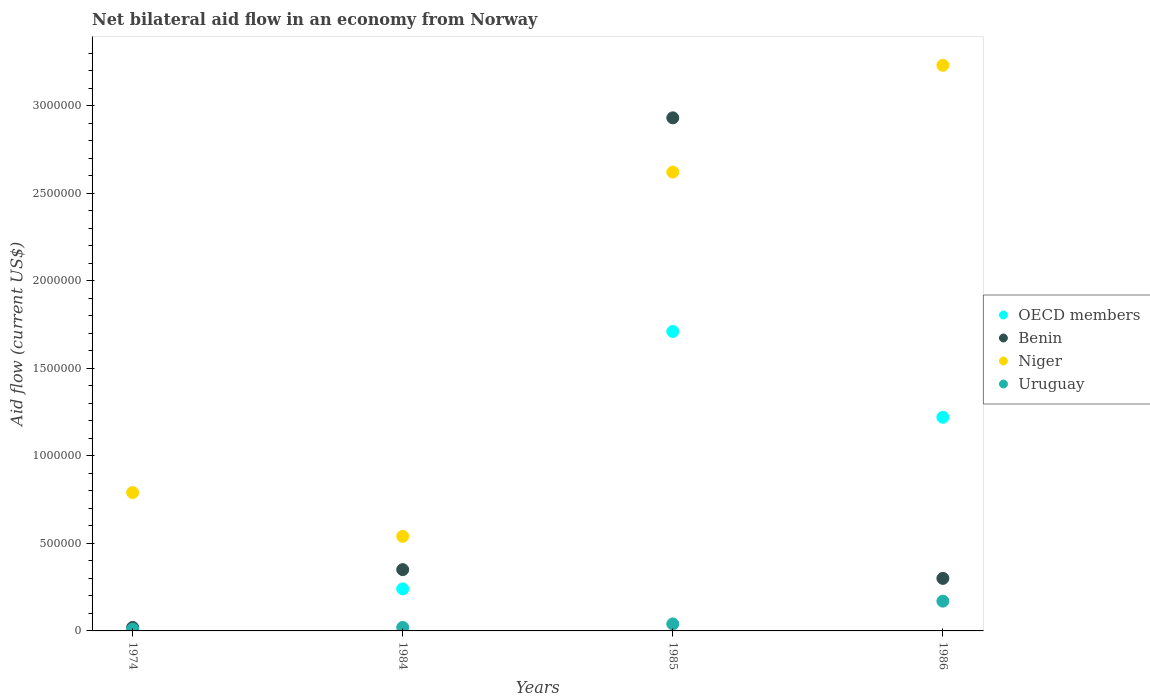Is the number of dotlines equal to the number of legend labels?
Keep it short and to the point. No. What is the net bilateral aid flow in OECD members in 1984?
Your answer should be very brief. 2.40e+05. Across all years, what is the maximum net bilateral aid flow in OECD members?
Offer a terse response. 1.71e+06. Across all years, what is the minimum net bilateral aid flow in Benin?
Offer a very short reply. 2.00e+04. What is the total net bilateral aid flow in OECD members in the graph?
Your answer should be very brief. 3.17e+06. What is the average net bilateral aid flow in Benin per year?
Your answer should be very brief. 9.00e+05. In how many years, is the net bilateral aid flow in Niger greater than 1500000 US$?
Your answer should be compact. 2. What is the ratio of the net bilateral aid flow in Uruguay in 1984 to that in 1985?
Give a very brief answer. 0.5. What is the difference between the highest and the lowest net bilateral aid flow in Benin?
Your answer should be very brief. 2.91e+06. Is it the case that in every year, the sum of the net bilateral aid flow in OECD members and net bilateral aid flow in Niger  is greater than the sum of net bilateral aid flow in Benin and net bilateral aid flow in Uruguay?
Your answer should be compact. No. Does the net bilateral aid flow in Benin monotonically increase over the years?
Your answer should be compact. No. Is the net bilateral aid flow in Niger strictly greater than the net bilateral aid flow in Uruguay over the years?
Offer a very short reply. Yes. How many dotlines are there?
Ensure brevity in your answer.  4. How many years are there in the graph?
Provide a short and direct response. 4. What is the difference between two consecutive major ticks on the Y-axis?
Provide a short and direct response. 5.00e+05. Does the graph contain any zero values?
Provide a short and direct response. Yes. Where does the legend appear in the graph?
Your response must be concise. Center right. How are the legend labels stacked?
Ensure brevity in your answer.  Vertical. What is the title of the graph?
Keep it short and to the point. Net bilateral aid flow in an economy from Norway. What is the label or title of the Y-axis?
Offer a terse response. Aid flow (current US$). What is the Aid flow (current US$) in Niger in 1974?
Provide a succinct answer. 7.90e+05. What is the Aid flow (current US$) in OECD members in 1984?
Provide a succinct answer. 2.40e+05. What is the Aid flow (current US$) of Benin in 1984?
Offer a terse response. 3.50e+05. What is the Aid flow (current US$) in Niger in 1984?
Your response must be concise. 5.40e+05. What is the Aid flow (current US$) of Uruguay in 1984?
Your answer should be very brief. 2.00e+04. What is the Aid flow (current US$) of OECD members in 1985?
Offer a very short reply. 1.71e+06. What is the Aid flow (current US$) of Benin in 1985?
Ensure brevity in your answer.  2.93e+06. What is the Aid flow (current US$) in Niger in 1985?
Offer a very short reply. 2.62e+06. What is the Aid flow (current US$) of Uruguay in 1985?
Your response must be concise. 4.00e+04. What is the Aid flow (current US$) in OECD members in 1986?
Ensure brevity in your answer.  1.22e+06. What is the Aid flow (current US$) in Benin in 1986?
Ensure brevity in your answer.  3.00e+05. What is the Aid flow (current US$) in Niger in 1986?
Your response must be concise. 3.23e+06. What is the Aid flow (current US$) of Uruguay in 1986?
Ensure brevity in your answer.  1.70e+05. Across all years, what is the maximum Aid flow (current US$) of OECD members?
Provide a succinct answer. 1.71e+06. Across all years, what is the maximum Aid flow (current US$) of Benin?
Provide a succinct answer. 2.93e+06. Across all years, what is the maximum Aid flow (current US$) in Niger?
Your response must be concise. 3.23e+06. Across all years, what is the maximum Aid flow (current US$) in Uruguay?
Your answer should be compact. 1.70e+05. Across all years, what is the minimum Aid flow (current US$) in OECD members?
Provide a succinct answer. 0. Across all years, what is the minimum Aid flow (current US$) in Niger?
Your response must be concise. 5.40e+05. What is the total Aid flow (current US$) of OECD members in the graph?
Provide a succinct answer. 3.17e+06. What is the total Aid flow (current US$) in Benin in the graph?
Offer a very short reply. 3.60e+06. What is the total Aid flow (current US$) in Niger in the graph?
Provide a succinct answer. 7.18e+06. What is the total Aid flow (current US$) in Uruguay in the graph?
Offer a terse response. 2.40e+05. What is the difference between the Aid flow (current US$) of Benin in 1974 and that in 1984?
Your response must be concise. -3.30e+05. What is the difference between the Aid flow (current US$) in Niger in 1974 and that in 1984?
Keep it short and to the point. 2.50e+05. What is the difference between the Aid flow (current US$) in Uruguay in 1974 and that in 1984?
Keep it short and to the point. -10000. What is the difference between the Aid flow (current US$) of Benin in 1974 and that in 1985?
Your response must be concise. -2.91e+06. What is the difference between the Aid flow (current US$) of Niger in 1974 and that in 1985?
Offer a terse response. -1.83e+06. What is the difference between the Aid flow (current US$) of Benin in 1974 and that in 1986?
Your answer should be compact. -2.80e+05. What is the difference between the Aid flow (current US$) in Niger in 1974 and that in 1986?
Give a very brief answer. -2.44e+06. What is the difference between the Aid flow (current US$) in Uruguay in 1974 and that in 1986?
Provide a succinct answer. -1.60e+05. What is the difference between the Aid flow (current US$) of OECD members in 1984 and that in 1985?
Ensure brevity in your answer.  -1.47e+06. What is the difference between the Aid flow (current US$) of Benin in 1984 and that in 1985?
Keep it short and to the point. -2.58e+06. What is the difference between the Aid flow (current US$) in Niger in 1984 and that in 1985?
Offer a very short reply. -2.08e+06. What is the difference between the Aid flow (current US$) of OECD members in 1984 and that in 1986?
Your answer should be compact. -9.80e+05. What is the difference between the Aid flow (current US$) in Benin in 1984 and that in 1986?
Give a very brief answer. 5.00e+04. What is the difference between the Aid flow (current US$) of Niger in 1984 and that in 1986?
Give a very brief answer. -2.69e+06. What is the difference between the Aid flow (current US$) in Uruguay in 1984 and that in 1986?
Offer a terse response. -1.50e+05. What is the difference between the Aid flow (current US$) in OECD members in 1985 and that in 1986?
Your answer should be very brief. 4.90e+05. What is the difference between the Aid flow (current US$) of Benin in 1985 and that in 1986?
Your answer should be compact. 2.63e+06. What is the difference between the Aid flow (current US$) in Niger in 1985 and that in 1986?
Your answer should be very brief. -6.10e+05. What is the difference between the Aid flow (current US$) in Uruguay in 1985 and that in 1986?
Provide a short and direct response. -1.30e+05. What is the difference between the Aid flow (current US$) in Benin in 1974 and the Aid flow (current US$) in Niger in 1984?
Your answer should be very brief. -5.20e+05. What is the difference between the Aid flow (current US$) in Niger in 1974 and the Aid flow (current US$) in Uruguay in 1984?
Offer a terse response. 7.70e+05. What is the difference between the Aid flow (current US$) in Benin in 1974 and the Aid flow (current US$) in Niger in 1985?
Give a very brief answer. -2.60e+06. What is the difference between the Aid flow (current US$) in Niger in 1974 and the Aid flow (current US$) in Uruguay in 1985?
Ensure brevity in your answer.  7.50e+05. What is the difference between the Aid flow (current US$) of Benin in 1974 and the Aid flow (current US$) of Niger in 1986?
Keep it short and to the point. -3.21e+06. What is the difference between the Aid flow (current US$) in Benin in 1974 and the Aid flow (current US$) in Uruguay in 1986?
Your answer should be compact. -1.50e+05. What is the difference between the Aid flow (current US$) of Niger in 1974 and the Aid flow (current US$) of Uruguay in 1986?
Give a very brief answer. 6.20e+05. What is the difference between the Aid flow (current US$) of OECD members in 1984 and the Aid flow (current US$) of Benin in 1985?
Make the answer very short. -2.69e+06. What is the difference between the Aid flow (current US$) of OECD members in 1984 and the Aid flow (current US$) of Niger in 1985?
Give a very brief answer. -2.38e+06. What is the difference between the Aid flow (current US$) in Benin in 1984 and the Aid flow (current US$) in Niger in 1985?
Give a very brief answer. -2.27e+06. What is the difference between the Aid flow (current US$) in Benin in 1984 and the Aid flow (current US$) in Uruguay in 1985?
Give a very brief answer. 3.10e+05. What is the difference between the Aid flow (current US$) in OECD members in 1984 and the Aid flow (current US$) in Niger in 1986?
Your answer should be compact. -2.99e+06. What is the difference between the Aid flow (current US$) in OECD members in 1984 and the Aid flow (current US$) in Uruguay in 1986?
Your response must be concise. 7.00e+04. What is the difference between the Aid flow (current US$) in Benin in 1984 and the Aid flow (current US$) in Niger in 1986?
Make the answer very short. -2.88e+06. What is the difference between the Aid flow (current US$) of Niger in 1984 and the Aid flow (current US$) of Uruguay in 1986?
Your answer should be very brief. 3.70e+05. What is the difference between the Aid flow (current US$) in OECD members in 1985 and the Aid flow (current US$) in Benin in 1986?
Your answer should be very brief. 1.41e+06. What is the difference between the Aid flow (current US$) of OECD members in 1985 and the Aid flow (current US$) of Niger in 1986?
Your answer should be very brief. -1.52e+06. What is the difference between the Aid flow (current US$) in OECD members in 1985 and the Aid flow (current US$) in Uruguay in 1986?
Make the answer very short. 1.54e+06. What is the difference between the Aid flow (current US$) in Benin in 1985 and the Aid flow (current US$) in Uruguay in 1986?
Keep it short and to the point. 2.76e+06. What is the difference between the Aid flow (current US$) in Niger in 1985 and the Aid flow (current US$) in Uruguay in 1986?
Offer a very short reply. 2.45e+06. What is the average Aid flow (current US$) in OECD members per year?
Offer a very short reply. 7.92e+05. What is the average Aid flow (current US$) in Niger per year?
Make the answer very short. 1.80e+06. In the year 1974, what is the difference between the Aid flow (current US$) of Benin and Aid flow (current US$) of Niger?
Offer a very short reply. -7.70e+05. In the year 1974, what is the difference between the Aid flow (current US$) in Niger and Aid flow (current US$) in Uruguay?
Give a very brief answer. 7.80e+05. In the year 1984, what is the difference between the Aid flow (current US$) in OECD members and Aid flow (current US$) in Benin?
Offer a very short reply. -1.10e+05. In the year 1984, what is the difference between the Aid flow (current US$) of Benin and Aid flow (current US$) of Uruguay?
Your answer should be very brief. 3.30e+05. In the year 1984, what is the difference between the Aid flow (current US$) of Niger and Aid flow (current US$) of Uruguay?
Keep it short and to the point. 5.20e+05. In the year 1985, what is the difference between the Aid flow (current US$) in OECD members and Aid flow (current US$) in Benin?
Provide a succinct answer. -1.22e+06. In the year 1985, what is the difference between the Aid flow (current US$) of OECD members and Aid flow (current US$) of Niger?
Make the answer very short. -9.10e+05. In the year 1985, what is the difference between the Aid flow (current US$) of OECD members and Aid flow (current US$) of Uruguay?
Offer a terse response. 1.67e+06. In the year 1985, what is the difference between the Aid flow (current US$) of Benin and Aid flow (current US$) of Uruguay?
Give a very brief answer. 2.89e+06. In the year 1985, what is the difference between the Aid flow (current US$) in Niger and Aid flow (current US$) in Uruguay?
Provide a short and direct response. 2.58e+06. In the year 1986, what is the difference between the Aid flow (current US$) in OECD members and Aid flow (current US$) in Benin?
Provide a succinct answer. 9.20e+05. In the year 1986, what is the difference between the Aid flow (current US$) in OECD members and Aid flow (current US$) in Niger?
Your answer should be compact. -2.01e+06. In the year 1986, what is the difference between the Aid flow (current US$) of OECD members and Aid flow (current US$) of Uruguay?
Your answer should be very brief. 1.05e+06. In the year 1986, what is the difference between the Aid flow (current US$) in Benin and Aid flow (current US$) in Niger?
Offer a very short reply. -2.93e+06. In the year 1986, what is the difference between the Aid flow (current US$) of Niger and Aid flow (current US$) of Uruguay?
Provide a succinct answer. 3.06e+06. What is the ratio of the Aid flow (current US$) in Benin in 1974 to that in 1984?
Provide a succinct answer. 0.06. What is the ratio of the Aid flow (current US$) of Niger in 1974 to that in 1984?
Offer a terse response. 1.46. What is the ratio of the Aid flow (current US$) in Uruguay in 1974 to that in 1984?
Provide a succinct answer. 0.5. What is the ratio of the Aid flow (current US$) of Benin in 1974 to that in 1985?
Keep it short and to the point. 0.01. What is the ratio of the Aid flow (current US$) in Niger in 1974 to that in 1985?
Ensure brevity in your answer.  0.3. What is the ratio of the Aid flow (current US$) in Uruguay in 1974 to that in 1985?
Your answer should be very brief. 0.25. What is the ratio of the Aid flow (current US$) in Benin in 1974 to that in 1986?
Give a very brief answer. 0.07. What is the ratio of the Aid flow (current US$) in Niger in 1974 to that in 1986?
Make the answer very short. 0.24. What is the ratio of the Aid flow (current US$) in Uruguay in 1974 to that in 1986?
Provide a succinct answer. 0.06. What is the ratio of the Aid flow (current US$) of OECD members in 1984 to that in 1985?
Keep it short and to the point. 0.14. What is the ratio of the Aid flow (current US$) in Benin in 1984 to that in 1985?
Your answer should be very brief. 0.12. What is the ratio of the Aid flow (current US$) of Niger in 1984 to that in 1985?
Your answer should be very brief. 0.21. What is the ratio of the Aid flow (current US$) in OECD members in 1984 to that in 1986?
Ensure brevity in your answer.  0.2. What is the ratio of the Aid flow (current US$) of Benin in 1984 to that in 1986?
Keep it short and to the point. 1.17. What is the ratio of the Aid flow (current US$) in Niger in 1984 to that in 1986?
Give a very brief answer. 0.17. What is the ratio of the Aid flow (current US$) in Uruguay in 1984 to that in 1986?
Offer a terse response. 0.12. What is the ratio of the Aid flow (current US$) in OECD members in 1985 to that in 1986?
Give a very brief answer. 1.4. What is the ratio of the Aid flow (current US$) of Benin in 1985 to that in 1986?
Offer a terse response. 9.77. What is the ratio of the Aid flow (current US$) in Niger in 1985 to that in 1986?
Your response must be concise. 0.81. What is the ratio of the Aid flow (current US$) of Uruguay in 1985 to that in 1986?
Ensure brevity in your answer.  0.24. What is the difference between the highest and the second highest Aid flow (current US$) in OECD members?
Your answer should be very brief. 4.90e+05. What is the difference between the highest and the second highest Aid flow (current US$) of Benin?
Make the answer very short. 2.58e+06. What is the difference between the highest and the lowest Aid flow (current US$) of OECD members?
Your answer should be very brief. 1.71e+06. What is the difference between the highest and the lowest Aid flow (current US$) in Benin?
Ensure brevity in your answer.  2.91e+06. What is the difference between the highest and the lowest Aid flow (current US$) in Niger?
Your answer should be very brief. 2.69e+06. 